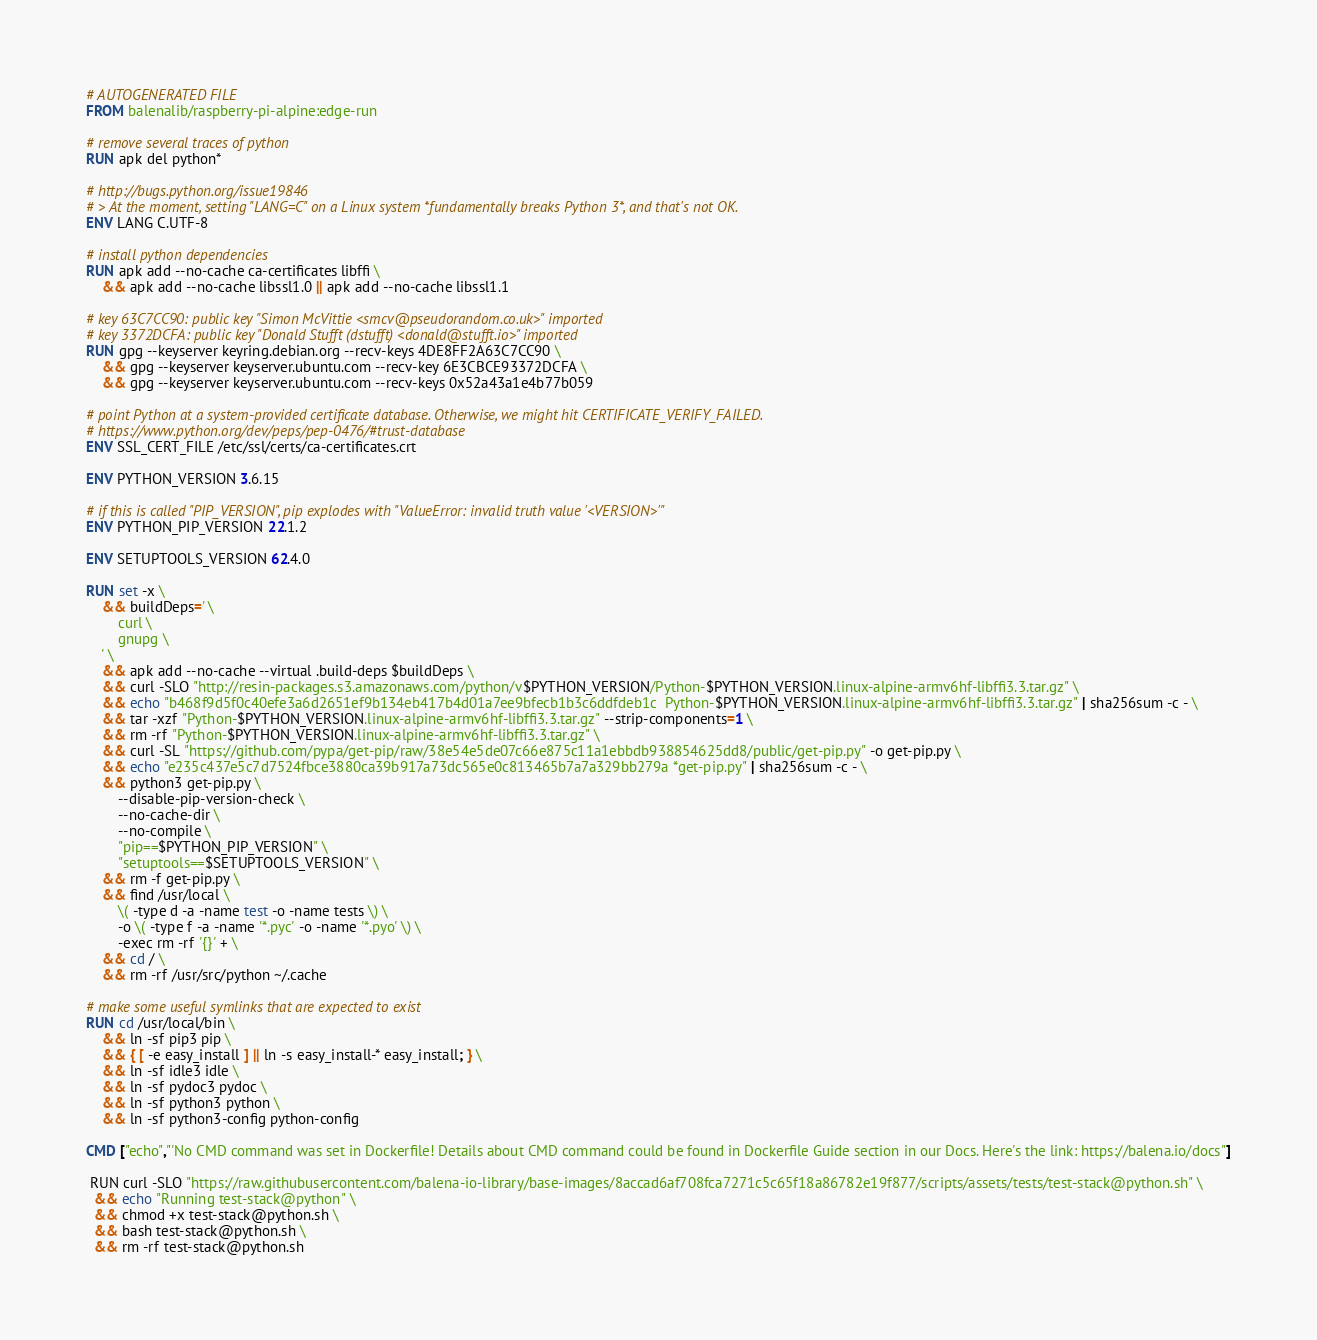<code> <loc_0><loc_0><loc_500><loc_500><_Dockerfile_># AUTOGENERATED FILE
FROM balenalib/raspberry-pi-alpine:edge-run

# remove several traces of python
RUN apk del python*

# http://bugs.python.org/issue19846
# > At the moment, setting "LANG=C" on a Linux system *fundamentally breaks Python 3*, and that's not OK.
ENV LANG C.UTF-8

# install python dependencies
RUN apk add --no-cache ca-certificates libffi \
	&& apk add --no-cache libssl1.0 || apk add --no-cache libssl1.1

# key 63C7CC90: public key "Simon McVittie <smcv@pseudorandom.co.uk>" imported
# key 3372DCFA: public key "Donald Stufft (dstufft) <donald@stufft.io>" imported
RUN gpg --keyserver keyring.debian.org --recv-keys 4DE8FF2A63C7CC90 \
	&& gpg --keyserver keyserver.ubuntu.com --recv-key 6E3CBCE93372DCFA \
	&& gpg --keyserver keyserver.ubuntu.com --recv-keys 0x52a43a1e4b77b059

# point Python at a system-provided certificate database. Otherwise, we might hit CERTIFICATE_VERIFY_FAILED.
# https://www.python.org/dev/peps/pep-0476/#trust-database
ENV SSL_CERT_FILE /etc/ssl/certs/ca-certificates.crt

ENV PYTHON_VERSION 3.6.15

# if this is called "PIP_VERSION", pip explodes with "ValueError: invalid truth value '<VERSION>'"
ENV PYTHON_PIP_VERSION 22.1.2

ENV SETUPTOOLS_VERSION 62.4.0

RUN set -x \
	&& buildDeps=' \
		curl \
		gnupg \
	' \
	&& apk add --no-cache --virtual .build-deps $buildDeps \
	&& curl -SLO "http://resin-packages.s3.amazonaws.com/python/v$PYTHON_VERSION/Python-$PYTHON_VERSION.linux-alpine-armv6hf-libffi3.3.tar.gz" \
	&& echo "b468f9d5f0c40efe3a6d2651ef9b134eb417b4d01a7ee9bfecb1b3c6ddfdeb1c  Python-$PYTHON_VERSION.linux-alpine-armv6hf-libffi3.3.tar.gz" | sha256sum -c - \
	&& tar -xzf "Python-$PYTHON_VERSION.linux-alpine-armv6hf-libffi3.3.tar.gz" --strip-components=1 \
	&& rm -rf "Python-$PYTHON_VERSION.linux-alpine-armv6hf-libffi3.3.tar.gz" \
	&& curl -SL "https://github.com/pypa/get-pip/raw/38e54e5de07c66e875c11a1ebbdb938854625dd8/public/get-pip.py" -o get-pip.py \
    && echo "e235c437e5c7d7524fbce3880ca39b917a73dc565e0c813465b7a7a329bb279a *get-pip.py" | sha256sum -c - \
    && python3 get-pip.py \
        --disable-pip-version-check \
        --no-cache-dir \
        --no-compile \
        "pip==$PYTHON_PIP_VERSION" \
        "setuptools==$SETUPTOOLS_VERSION" \
	&& rm -f get-pip.py \
	&& find /usr/local \
		\( -type d -a -name test -o -name tests \) \
		-o \( -type f -a -name '*.pyc' -o -name '*.pyo' \) \
		-exec rm -rf '{}' + \
	&& cd / \
	&& rm -rf /usr/src/python ~/.cache

# make some useful symlinks that are expected to exist
RUN cd /usr/local/bin \
	&& ln -sf pip3 pip \
	&& { [ -e easy_install ] || ln -s easy_install-* easy_install; } \
	&& ln -sf idle3 idle \
	&& ln -sf pydoc3 pydoc \
	&& ln -sf python3 python \
	&& ln -sf python3-config python-config

CMD ["echo","'No CMD command was set in Dockerfile! Details about CMD command could be found in Dockerfile Guide section in our Docs. Here's the link: https://balena.io/docs"]

 RUN curl -SLO "https://raw.githubusercontent.com/balena-io-library/base-images/8accad6af708fca7271c5c65f18a86782e19f877/scripts/assets/tests/test-stack@python.sh" \
  && echo "Running test-stack@python" \
  && chmod +x test-stack@python.sh \
  && bash test-stack@python.sh \
  && rm -rf test-stack@python.sh 
</code> 